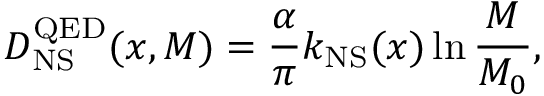Convert formula to latex. <formula><loc_0><loc_0><loc_500><loc_500>D _ { N S } ^ { Q E D } ( x , M ) = \frac { \alpha } { \pi } k _ { N S } ( x ) \ln \frac { M } { M _ { 0 } } ,</formula> 